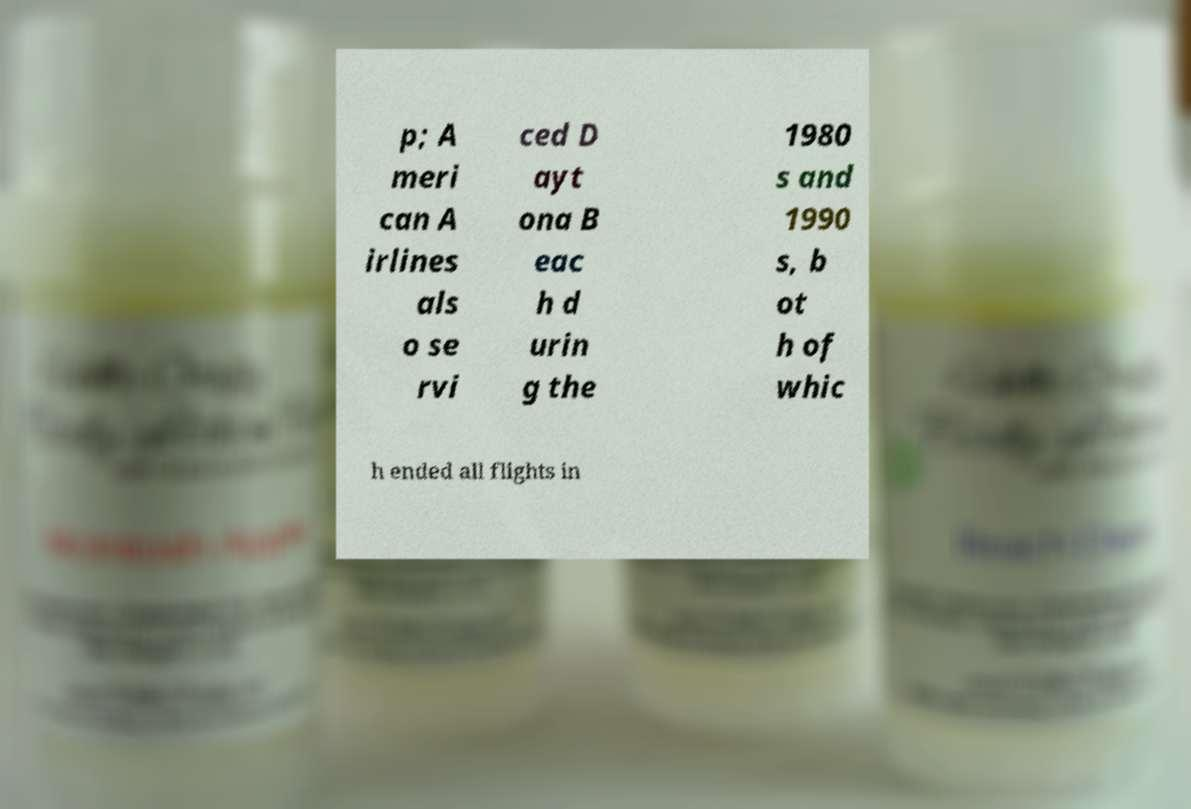Can you accurately transcribe the text from the provided image for me? p; A meri can A irlines als o se rvi ced D ayt ona B eac h d urin g the 1980 s and 1990 s, b ot h of whic h ended all flights in 